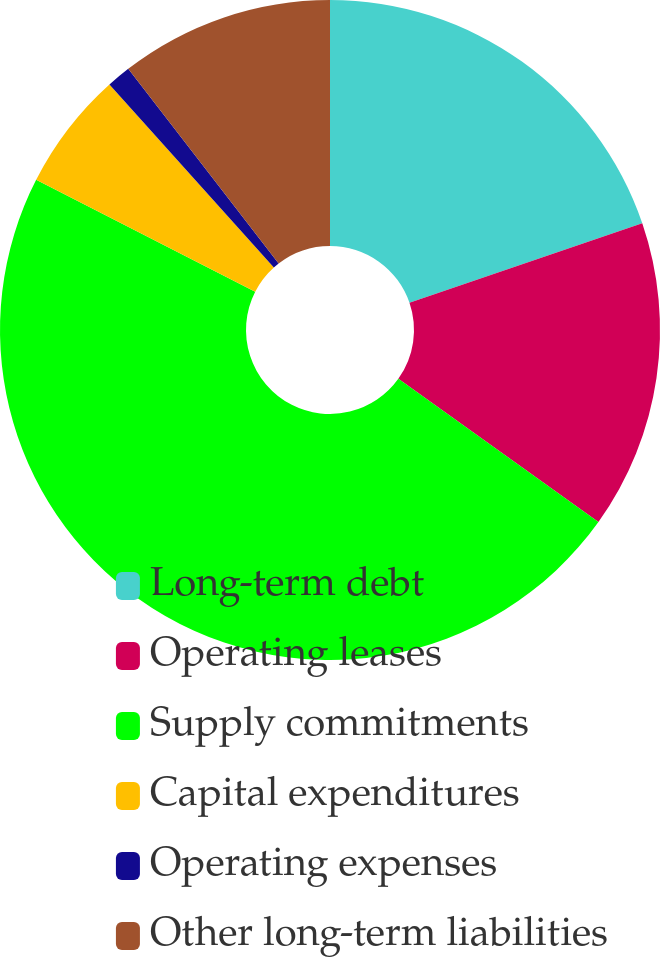Convert chart. <chart><loc_0><loc_0><loc_500><loc_500><pie_chart><fcel>Long-term debt<fcel>Operating leases<fcel>Supply commitments<fcel>Capital expenditures<fcel>Operating expenses<fcel>Other long-term liabilities<nl><fcel>19.76%<fcel>15.12%<fcel>47.64%<fcel>5.83%<fcel>1.18%<fcel>10.47%<nl></chart> 